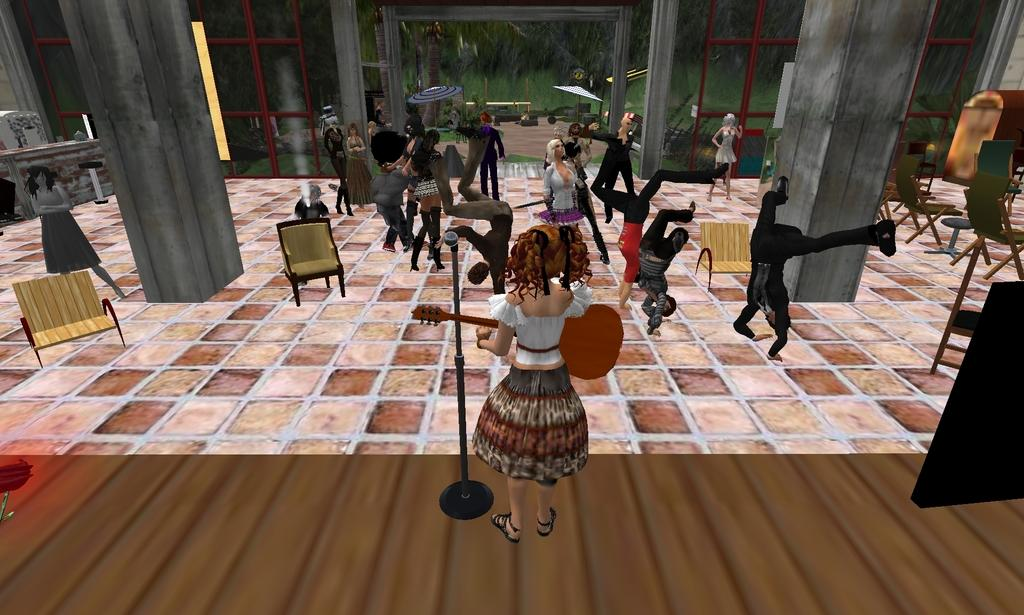What type of image is being described? The image is an animation. Can you describe the main subject in the image? There is a woman standing in the middle of the image. What is the woman doing in the image? The woman is playing the guitar. What else can be observed about the people in the image? There are people performing different actions in the image. What color is the silver prison in the image? There is no silver prison present in the image. How does the woman express her hate towards the audience in the image? The image does not depict any expressions of hate, and the woman is playing the guitar, not interacting with an audience. 